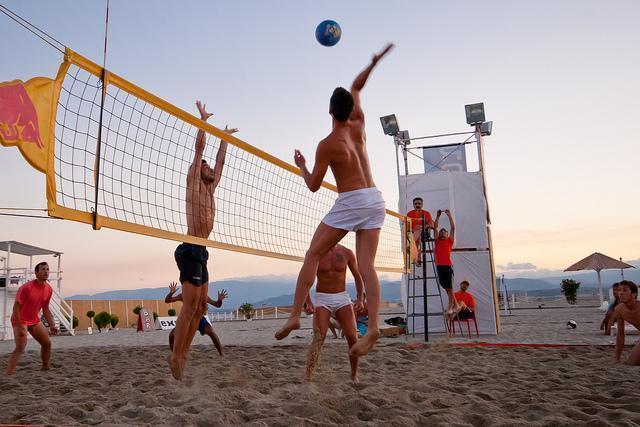What type volleyball is being played here?
Answer the question by selecting the correct answer among the 4 following choices and explain your choice with a short sentence. The answer should be formatted with the following format: `Answer: choice
Rationale: rationale.`
Options: Lawn, tennis, beach, professional surface. Answer: beach.
Rationale: The playing surface is outside and is made out of sand, not grass or wood. it is not a tennis court. 